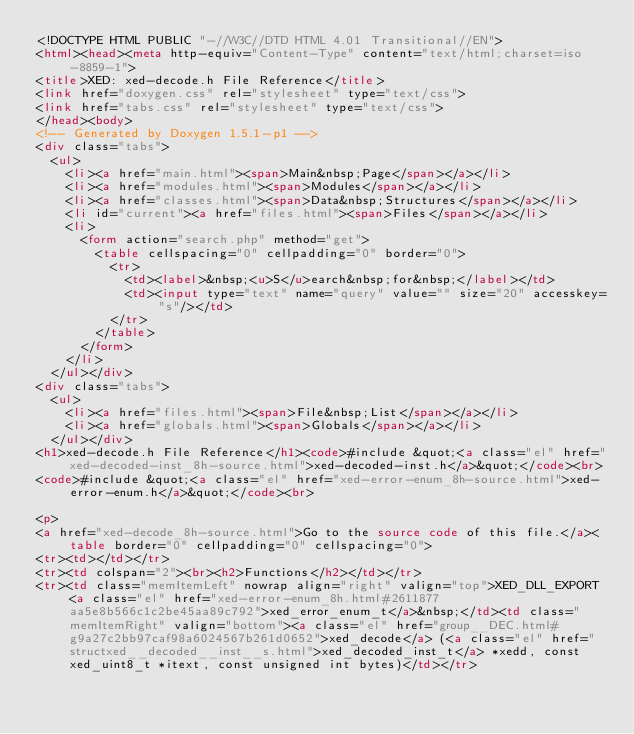<code> <loc_0><loc_0><loc_500><loc_500><_HTML_><!DOCTYPE HTML PUBLIC "-//W3C//DTD HTML 4.01 Transitional//EN">
<html><head><meta http-equiv="Content-Type" content="text/html;charset=iso-8859-1">
<title>XED: xed-decode.h File Reference</title>
<link href="doxygen.css" rel="stylesheet" type="text/css">
<link href="tabs.css" rel="stylesheet" type="text/css">
</head><body>
<!-- Generated by Doxygen 1.5.1-p1 -->
<div class="tabs">
  <ul>
    <li><a href="main.html"><span>Main&nbsp;Page</span></a></li>
    <li><a href="modules.html"><span>Modules</span></a></li>
    <li><a href="classes.html"><span>Data&nbsp;Structures</span></a></li>
    <li id="current"><a href="files.html"><span>Files</span></a></li>
    <li>
      <form action="search.php" method="get">
        <table cellspacing="0" cellpadding="0" border="0">
          <tr>
            <td><label>&nbsp;<u>S</u>earch&nbsp;for&nbsp;</label></td>
            <td><input type="text" name="query" value="" size="20" accesskey="s"/></td>
          </tr>
        </table>
      </form>
    </li>
  </ul></div>
<div class="tabs">
  <ul>
    <li><a href="files.html"><span>File&nbsp;List</span></a></li>
    <li><a href="globals.html"><span>Globals</span></a></li>
  </ul></div>
<h1>xed-decode.h File Reference</h1><code>#include &quot;<a class="el" href="xed-decoded-inst_8h-source.html">xed-decoded-inst.h</a>&quot;</code><br>
<code>#include &quot;<a class="el" href="xed-error-enum_8h-source.html">xed-error-enum.h</a>&quot;</code><br>

<p>
<a href="xed-decode_8h-source.html">Go to the source code of this file.</a><table border="0" cellpadding="0" cellspacing="0">
<tr><td></td></tr>
<tr><td colspan="2"><br><h2>Functions</h2></td></tr>
<tr><td class="memItemLeft" nowrap align="right" valign="top">XED_DLL_EXPORT <a class="el" href="xed-error-enum_8h.html#2611877aa5e8b566c1c2be45aa89c792">xed_error_enum_t</a>&nbsp;</td><td class="memItemRight" valign="bottom"><a class="el" href="group__DEC.html#g9a27c2bb97caf98a6024567b261d0652">xed_decode</a> (<a class="el" href="structxed__decoded__inst__s.html">xed_decoded_inst_t</a> *xedd, const xed_uint8_t *itext, const unsigned int bytes)</td></tr>
</code> 